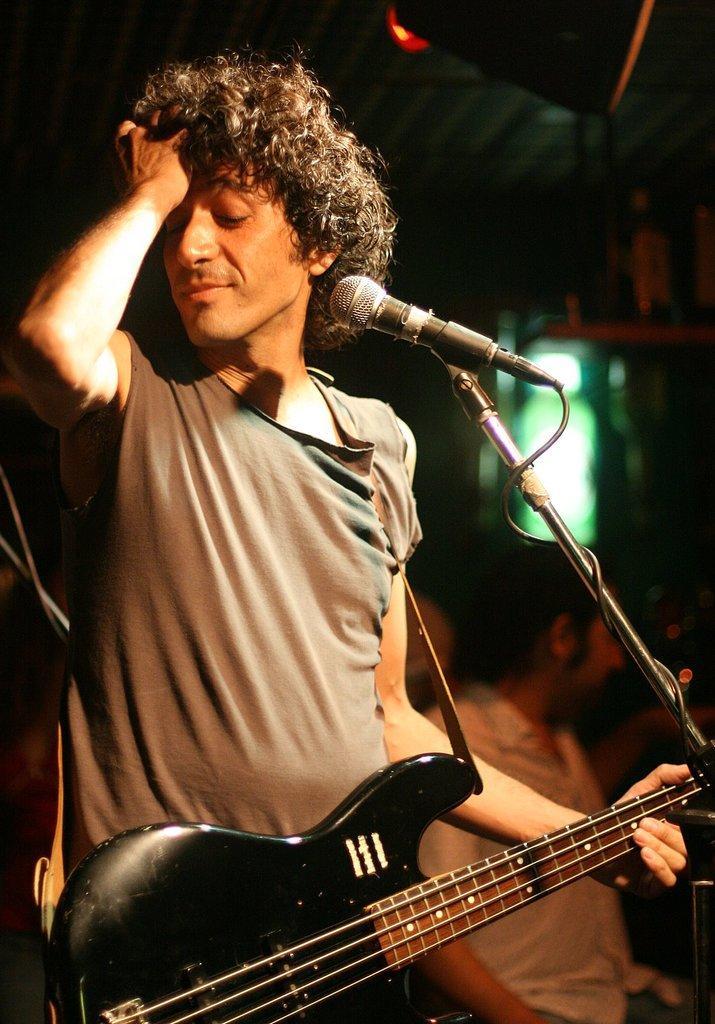Could you give a brief overview of what you see in this image? in the picture we can see a person holding a guitar and standing in front of a micro phone with the stand ,he is keeping his hand on his hair. 